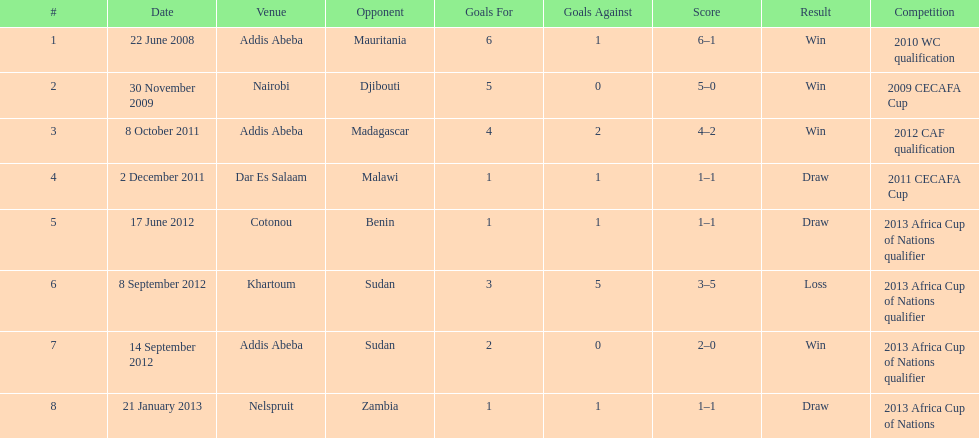True or false? in comparison, the ethiopian national team has more draws than wins. False. 